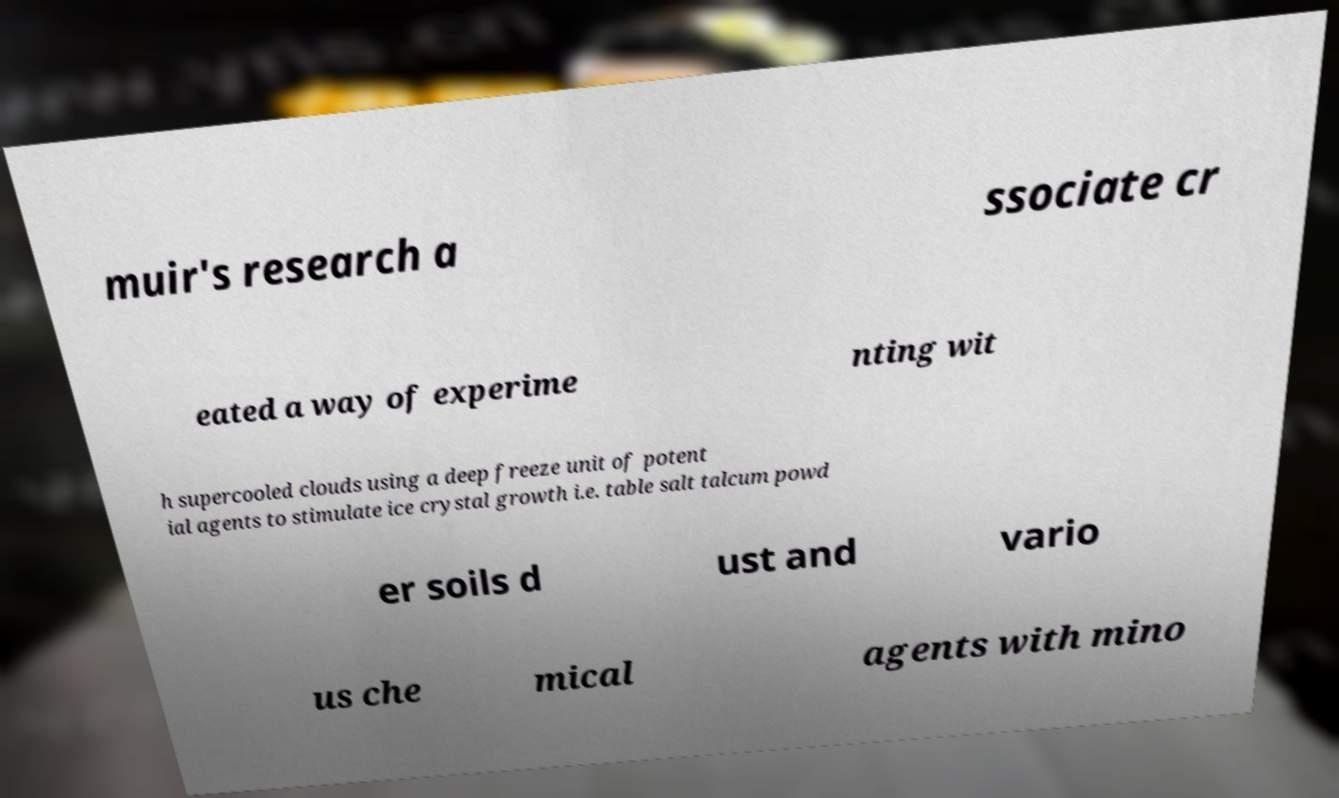Please read and relay the text visible in this image. What does it say? muir's research a ssociate cr eated a way of experime nting wit h supercooled clouds using a deep freeze unit of potent ial agents to stimulate ice crystal growth i.e. table salt talcum powd er soils d ust and vario us che mical agents with mino 